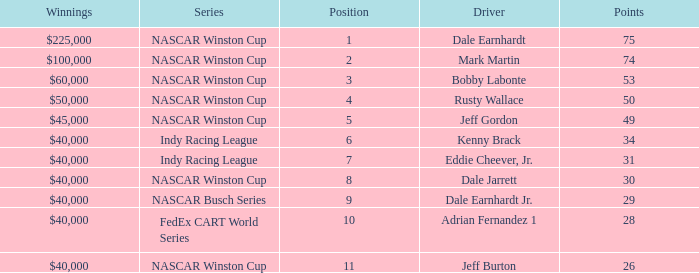In what series did Bobby Labonte drive? NASCAR Winston Cup. 